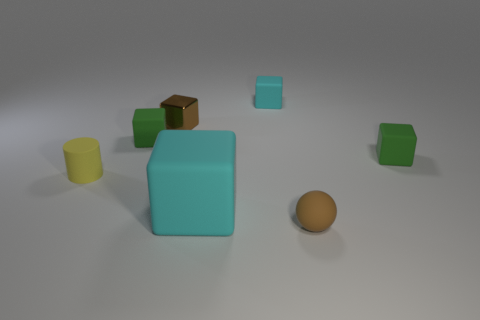Subtract all brown cubes. How many cubes are left? 4 Subtract all brown blocks. How many blocks are left? 4 Subtract all purple blocks. Subtract all cyan cylinders. How many blocks are left? 5 Add 2 spheres. How many objects exist? 9 Subtract all balls. How many objects are left? 6 Add 7 tiny brown rubber things. How many tiny brown rubber things are left? 8 Add 1 small yellow objects. How many small yellow objects exist? 2 Subtract 0 green balls. How many objects are left? 7 Subtract all big red matte blocks. Subtract all brown rubber objects. How many objects are left? 6 